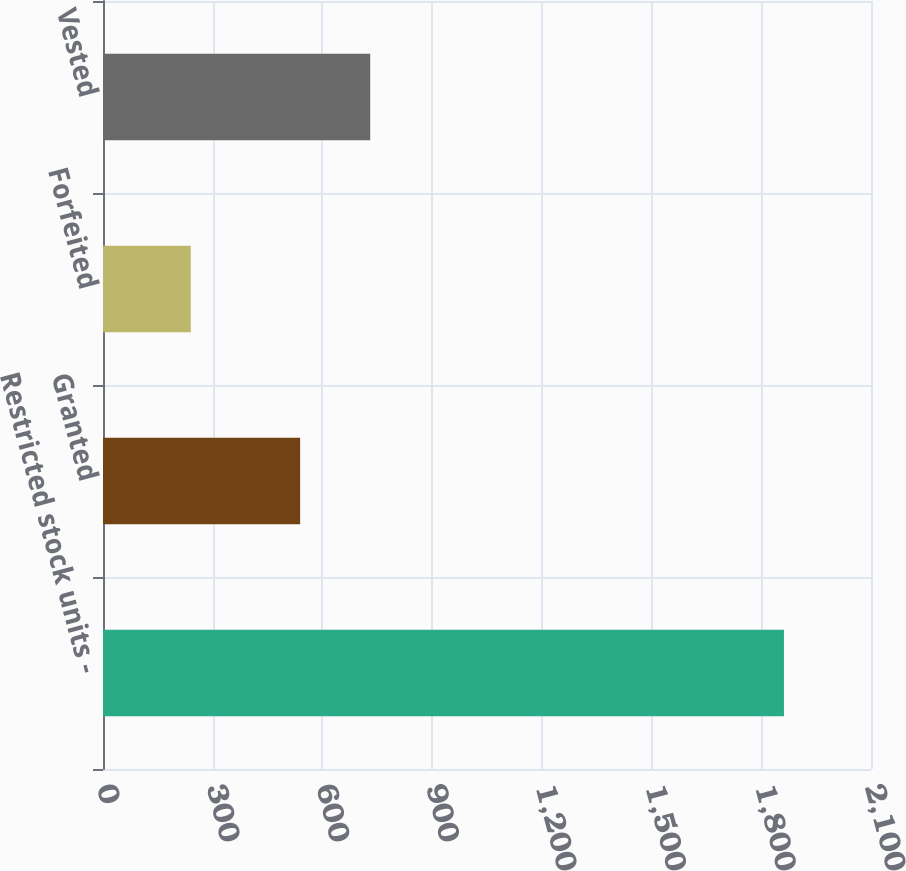Convert chart to OTSL. <chart><loc_0><loc_0><loc_500><loc_500><bar_chart><fcel>Restricted stock units -<fcel>Granted<fcel>Forfeited<fcel>Vested<nl><fcel>1862<fcel>539<fcel>240<fcel>730.7<nl></chart> 